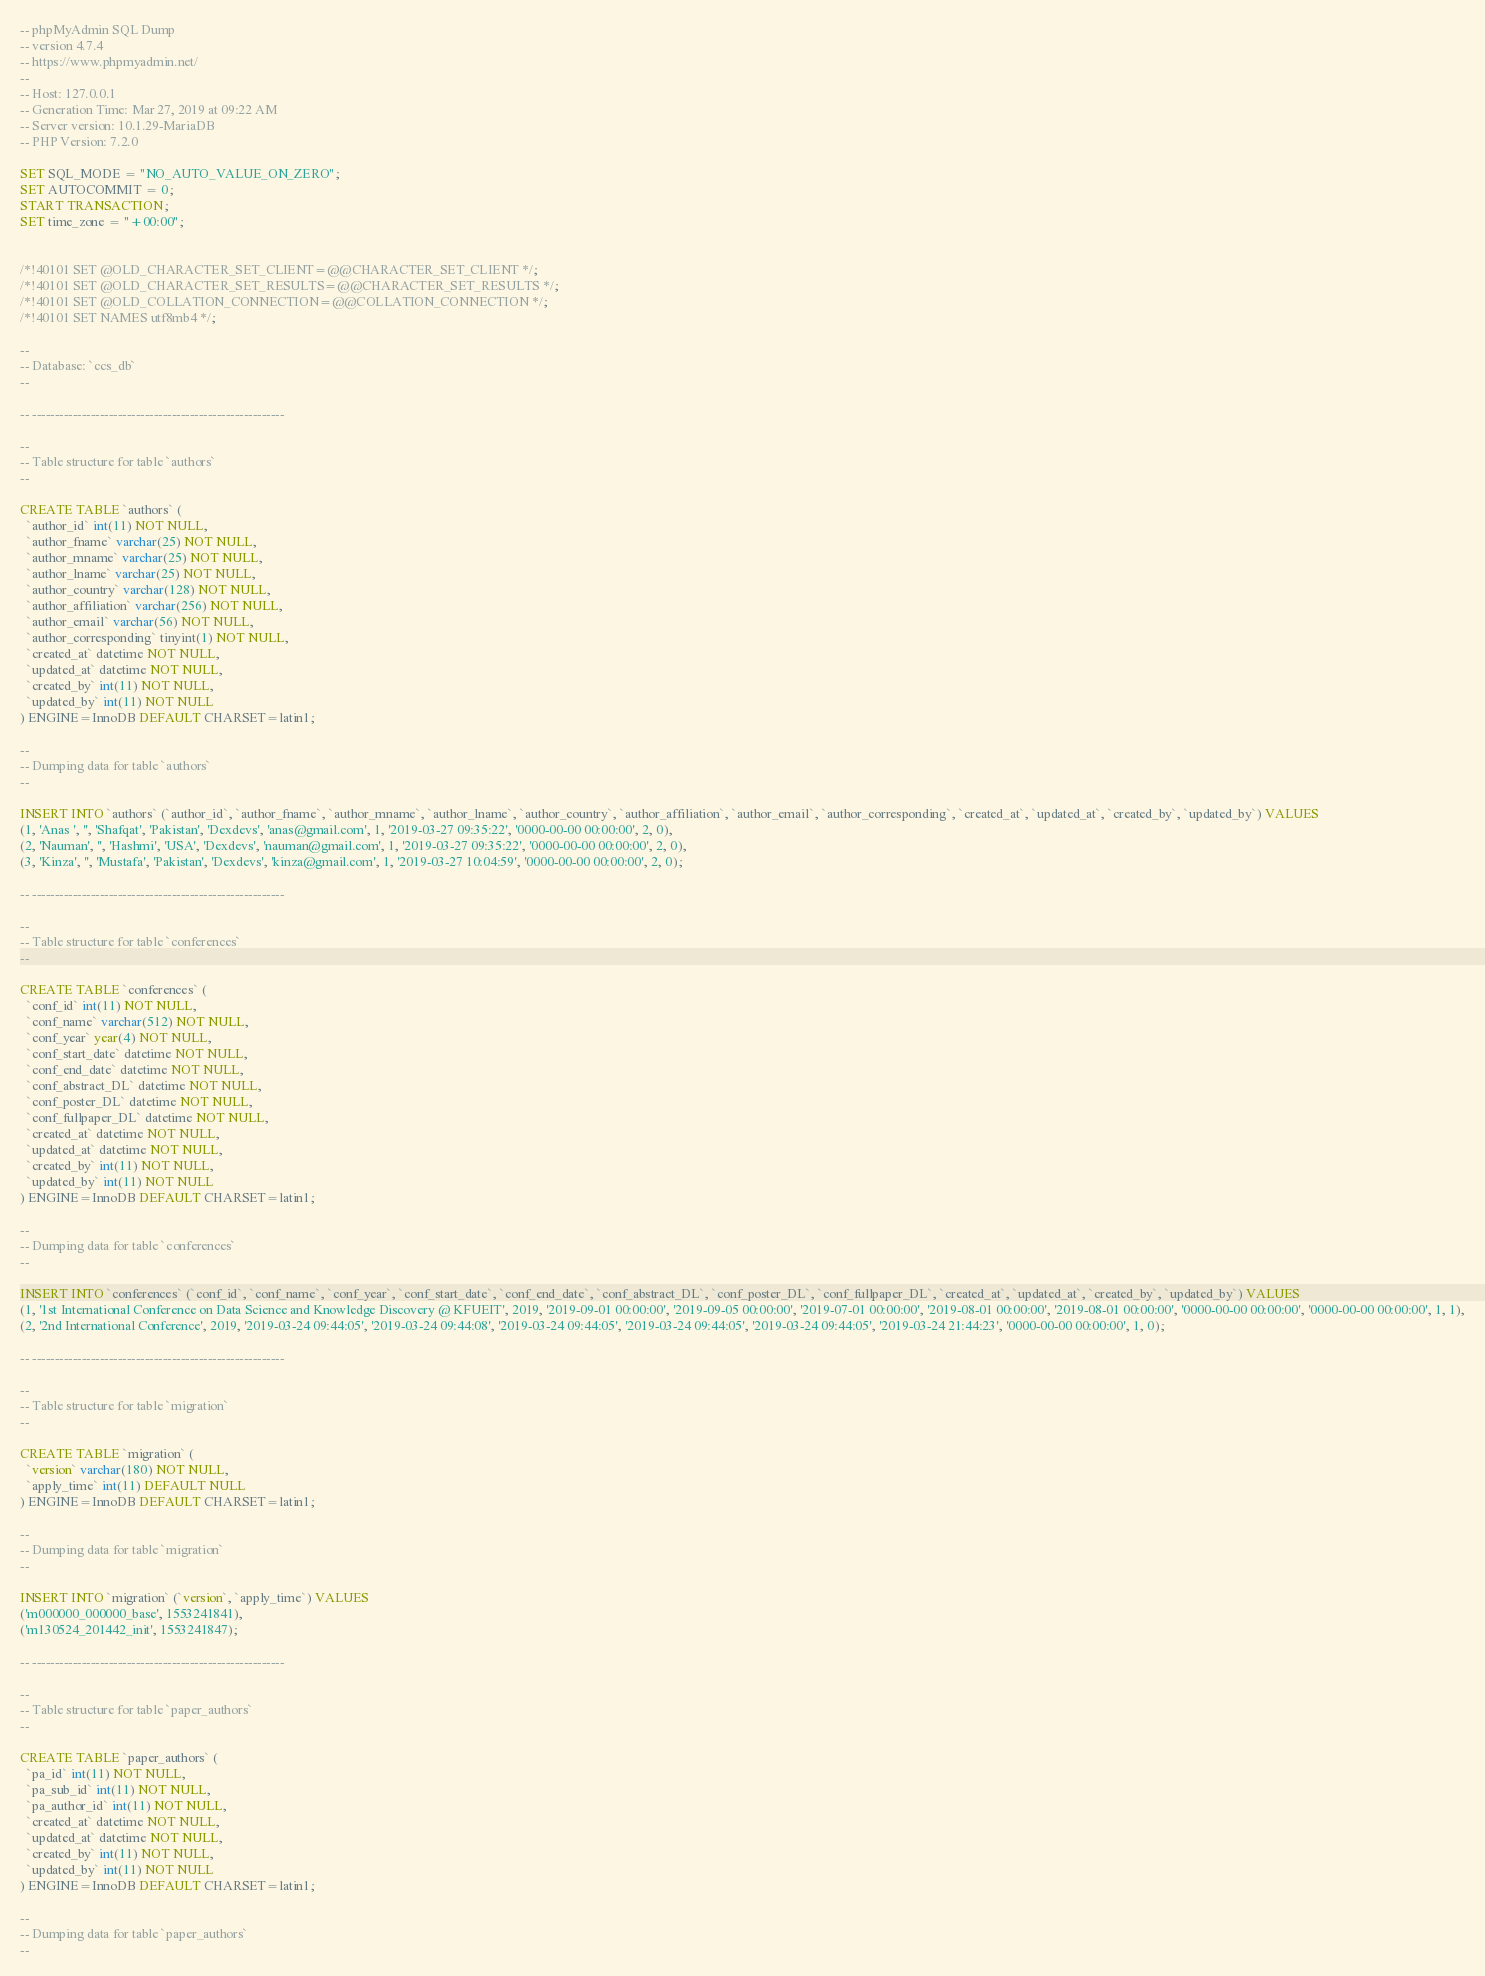Convert code to text. <code><loc_0><loc_0><loc_500><loc_500><_SQL_>-- phpMyAdmin SQL Dump
-- version 4.7.4
-- https://www.phpmyadmin.net/
--
-- Host: 127.0.0.1
-- Generation Time: Mar 27, 2019 at 09:22 AM
-- Server version: 10.1.29-MariaDB
-- PHP Version: 7.2.0

SET SQL_MODE = "NO_AUTO_VALUE_ON_ZERO";
SET AUTOCOMMIT = 0;
START TRANSACTION;
SET time_zone = "+00:00";


/*!40101 SET @OLD_CHARACTER_SET_CLIENT=@@CHARACTER_SET_CLIENT */;
/*!40101 SET @OLD_CHARACTER_SET_RESULTS=@@CHARACTER_SET_RESULTS */;
/*!40101 SET @OLD_COLLATION_CONNECTION=@@COLLATION_CONNECTION */;
/*!40101 SET NAMES utf8mb4 */;

--
-- Database: `ccs_db`
--

-- --------------------------------------------------------

--
-- Table structure for table `authors`
--

CREATE TABLE `authors` (
  `author_id` int(11) NOT NULL,
  `author_fname` varchar(25) NOT NULL,
  `author_mname` varchar(25) NOT NULL,
  `author_lname` varchar(25) NOT NULL,
  `author_country` varchar(128) NOT NULL,
  `author_affiliation` varchar(256) NOT NULL,
  `author_email` varchar(56) NOT NULL,
  `author_corresponding` tinyint(1) NOT NULL,
  `created_at` datetime NOT NULL,
  `updated_at` datetime NOT NULL,
  `created_by` int(11) NOT NULL,
  `updated_by` int(11) NOT NULL
) ENGINE=InnoDB DEFAULT CHARSET=latin1;

--
-- Dumping data for table `authors`
--

INSERT INTO `authors` (`author_id`, `author_fname`, `author_mname`, `author_lname`, `author_country`, `author_affiliation`, `author_email`, `author_corresponding`, `created_at`, `updated_at`, `created_by`, `updated_by`) VALUES
(1, 'Anas ', '', 'Shafqat', 'Pakistan', 'Dexdevs', 'anas@gmail.com', 1, '2019-03-27 09:35:22', '0000-00-00 00:00:00', 2, 0),
(2, 'Nauman', '', 'Hashmi', 'USA', 'Dexdevs', 'nauman@gmail.com', 1, '2019-03-27 09:35:22', '0000-00-00 00:00:00', 2, 0),
(3, 'Kinza', '', 'Mustafa', 'Pakistan', 'Dexdevs', 'kinza@gmail.com', 1, '2019-03-27 10:04:59', '0000-00-00 00:00:00', 2, 0);

-- --------------------------------------------------------

--
-- Table structure for table `conferences`
--

CREATE TABLE `conferences` (
  `conf_id` int(11) NOT NULL,
  `conf_name` varchar(512) NOT NULL,
  `conf_year` year(4) NOT NULL,
  `conf_start_date` datetime NOT NULL,
  `conf_end_date` datetime NOT NULL,
  `conf_abstract_DL` datetime NOT NULL,
  `conf_poster_DL` datetime NOT NULL,
  `conf_fullpaper_DL` datetime NOT NULL,
  `created_at` datetime NOT NULL,
  `updated_at` datetime NOT NULL,
  `created_by` int(11) NOT NULL,
  `updated_by` int(11) NOT NULL
) ENGINE=InnoDB DEFAULT CHARSET=latin1;

--
-- Dumping data for table `conferences`
--

INSERT INTO `conferences` (`conf_id`, `conf_name`, `conf_year`, `conf_start_date`, `conf_end_date`, `conf_abstract_DL`, `conf_poster_DL`, `conf_fullpaper_DL`, `created_at`, `updated_at`, `created_by`, `updated_by`) VALUES
(1, '1st International Conference on Data Science and Knowledge Discovery @ KFUEIT', 2019, '2019-09-01 00:00:00', '2019-09-05 00:00:00', '2019-07-01 00:00:00', '2019-08-01 00:00:00', '2019-08-01 00:00:00', '0000-00-00 00:00:00', '0000-00-00 00:00:00', 1, 1),
(2, '2nd International Conference', 2019, '2019-03-24 09:44:05', '2019-03-24 09:44:08', '2019-03-24 09:44:05', '2019-03-24 09:44:05', '2019-03-24 09:44:05', '2019-03-24 21:44:23', '0000-00-00 00:00:00', 1, 0);

-- --------------------------------------------------------

--
-- Table structure for table `migration`
--

CREATE TABLE `migration` (
  `version` varchar(180) NOT NULL,
  `apply_time` int(11) DEFAULT NULL
) ENGINE=InnoDB DEFAULT CHARSET=latin1;

--
-- Dumping data for table `migration`
--

INSERT INTO `migration` (`version`, `apply_time`) VALUES
('m000000_000000_base', 1553241841),
('m130524_201442_init', 1553241847);

-- --------------------------------------------------------

--
-- Table structure for table `paper_authors`
--

CREATE TABLE `paper_authors` (
  `pa_id` int(11) NOT NULL,
  `pa_sub_id` int(11) NOT NULL,
  `pa_author_id` int(11) NOT NULL,
  `created_at` datetime NOT NULL,
  `updated_at` datetime NOT NULL,
  `created_by` int(11) NOT NULL,
  `updated_by` int(11) NOT NULL
) ENGINE=InnoDB DEFAULT CHARSET=latin1;

--
-- Dumping data for table `paper_authors`
--
</code> 